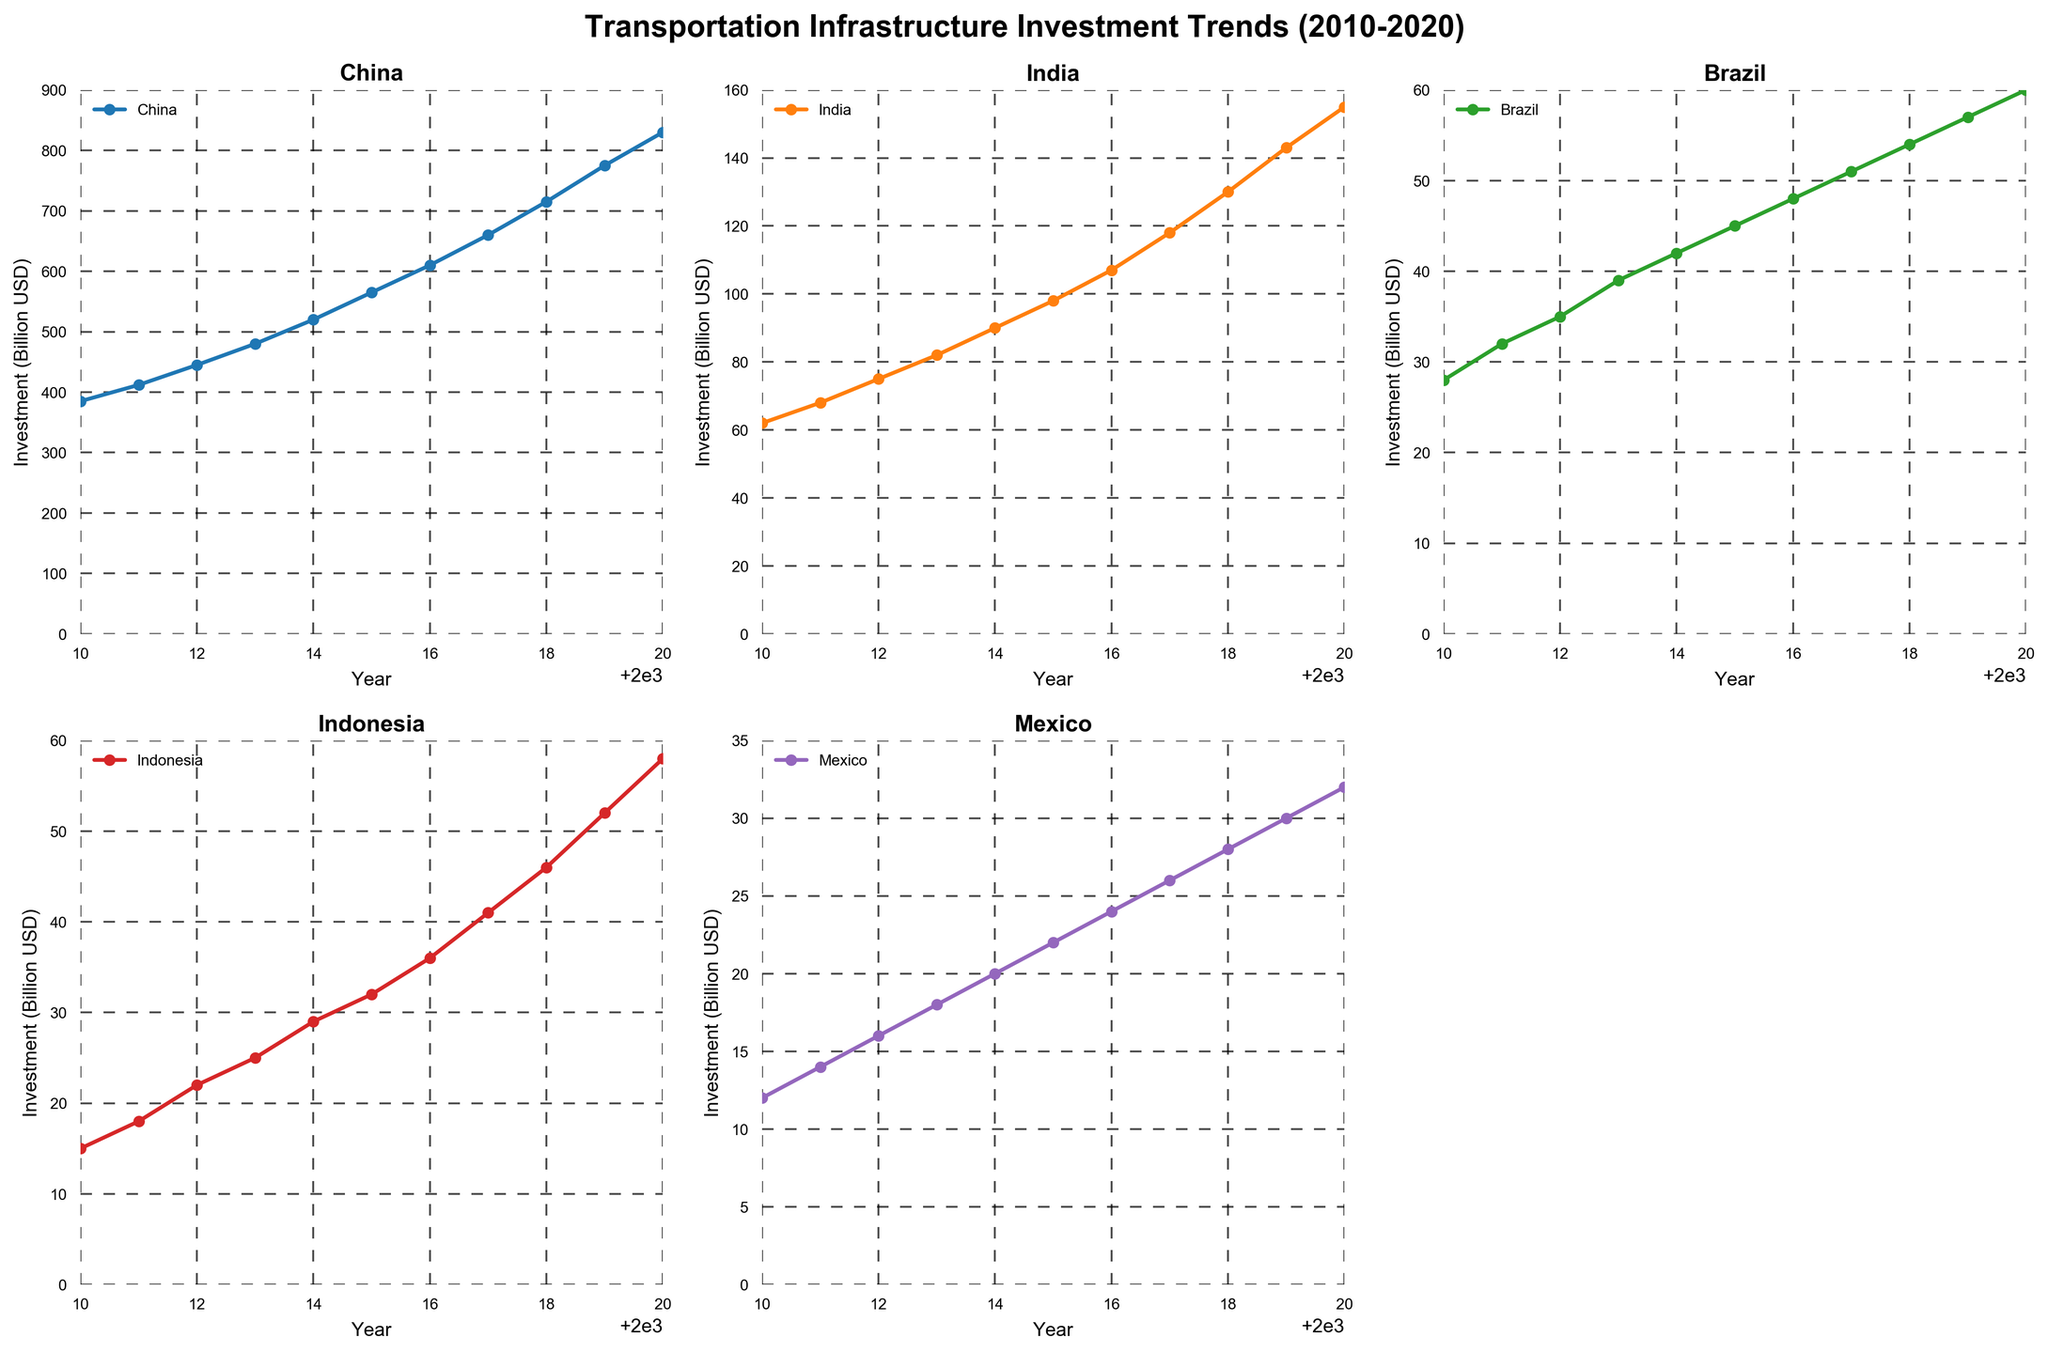What was the total investment in Transportation Infrastructure in China from 2010 to 2020? To find the total investment in China, sum up the yearly investments from 2010 to 2020. The values are: 385 + 412 + 445 + 480 + 520 + 565 + 610 + 660 + 715 + 775 + 830. The total is 6397 billion USD.
Answer: 6397 billion USD How does the investment trend in Indonesia from 2010 to 2020 compare to that in Mexico? To compare the investment trends, look at the line plots for Indonesia and Mexico. Both show an increasing trend, but the values for Indonesia are consistently higher. In 2020, Indonesia's investment is 58 billion USD, while Mexico's is 32 billion USD. This indicates a higher investment trend in Indonesia over the years.
Answer: Higher in Indonesia What was the average yearly investment in Transportation Infrastructure in Brazil between 2010 and 2020? To find the average yearly investment, sum the investments for Brazil from 2010 to 2020: 28 + 32 + 35 + 39 + 42 + 45 + 48 + 51 + 54 + 57 + 60. The total is 491 billion USD. Divide this by 11 to get the average: 491 / 11 ≈ 44.6 billion USD.
Answer: 44.6 billion USD In which year did India see the highest increase in investment compared to the previous year? To find the highest increase, calculate the difference year-by-year for India: 68-62 (6), 75-68 (7), 82-75 (7), 90-82 (8), 98-90 (8), 107-98 (9), 118-107 (11), 130-118 (12), 143-130 (13), 155-143 (12). The highest increase is from 2018 to 2019 (13 billion USD).
Answer: 2019 Which country had the steepest increase in investment from 2015 to 2020? Examine the slopes of the lines for each country from 2015 to 2020. For China, the increase is from 565 to 830 (265 billion USD). For India, the increase is from 98 to 155 (57 billion USD). For Brazil, the increase is from 45 to 60 (15 billion USD). For Indonesia, the increase is from 32 to 58 (26 billion USD). For Mexico, it is from 22 to 32 (10 billion USD). China has the steepest increase.
Answer: China 